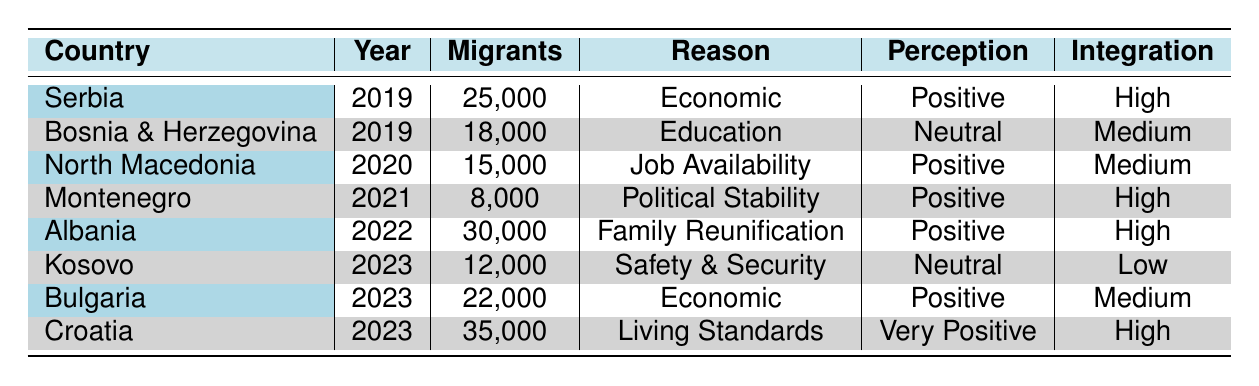What was the total number of migrants from the Balkans in 2022? In 2022, the only country listed is Albania with 30,000 migrants. Thus, the total number of migrants from the Balkans in 2022 is directly taken from this entry.
Answer: 30,000 Which country had the highest number of migrants in 2023? In 2023, there are three entries: Kosovo (12,000), Bulgaria (22,000), and Croatia (35,000). By comparing these numbers, Croatia has the highest number of migrants with 35,000.
Answer: Croatia Is the perception of the host country for North Macedonia in 2020 positive? The table states that North Macedonia’s perception of the host country in 2020 is "Positive," as indicated in the corresponding row.
Answer: Yes What is the average number of migrants from the countries listed in 2019? In 2019, Serbia had 25,000 and Bosnia and Herzegovina had 18,000. To find the average, sum these values (25,000 + 18,000 = 43,000) and divide by the number of countries (2). Therefore, the average is 43,000 / 2 = 21,500.
Answer: 21,500 Which country had a low integration success rate in 2023? The table shows that in 2023, Kosovo had a low integration success rate, as indicated in its row, while the other countries had medium or high rates.
Answer: Kosovo What is the reason for migration from Albania in 2022? According to the table, Albania had a migration reason listed as "Family Reunification" for the year 2022. This can be directly read from the corresponding row.
Answer: Family Reunification Which country has the least number of migrants in 2021? According to the table, Montenegro had the least number of migrants in 2021 with only 8,000. This can be deduced by comparing the number of migrants from all the countries in that specific year.
Answer: Montenegro What is the overall perception of the host country for countries with a high integration success rate? By analyzing the table, the countries with a high integration success rate are Serbia, Montenegro, Albania, and Croatia, which have perceptions listed as Positive (3 countries) and Very Positive (1 country). Thus, the overall perception can be categorized as predominantly positive.
Answer: Positive 